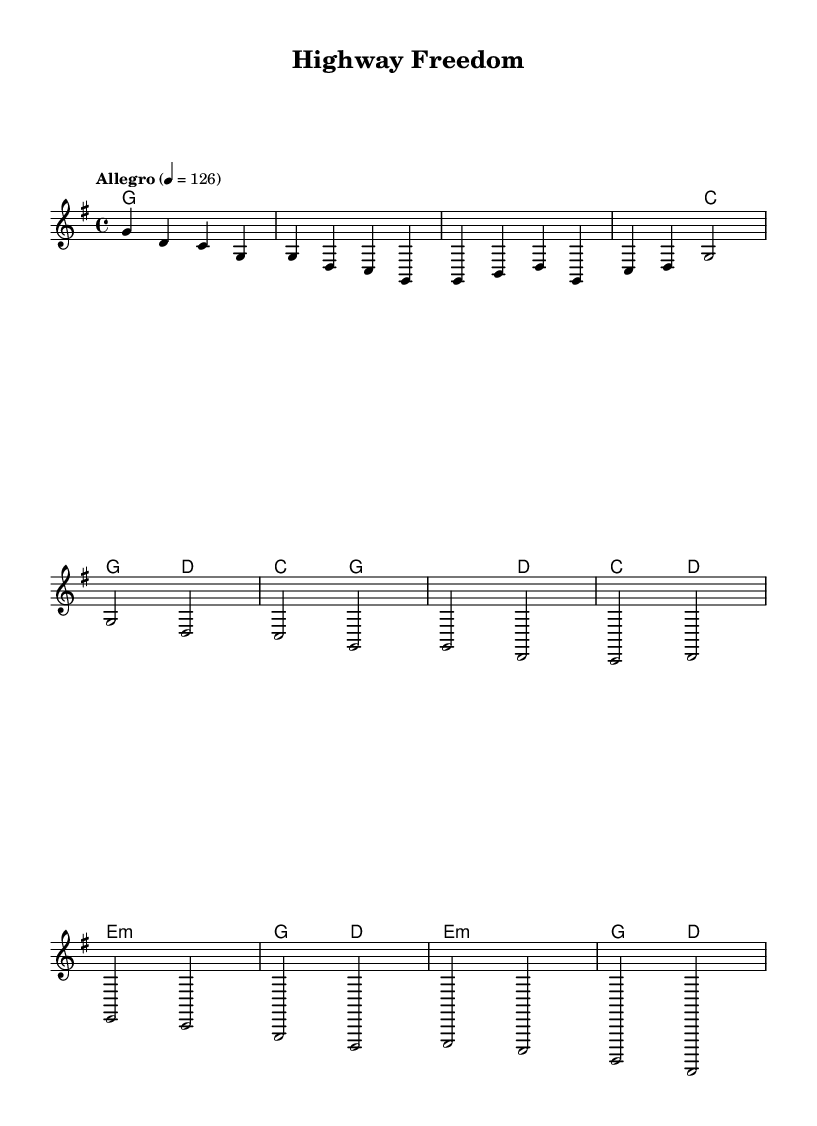What is the key signature of this music? The key signature is indicated by the number of sharps or flats at the beginning of the staff. In this case, the piece is in G major, which has one sharp (F#).
Answer: G major What is the time signature of this piece? The time signature is noted at the beginning of the staff and indicates how many beats are in each measure. Here, it shows 4/4, meaning there are four beats per measure.
Answer: 4/4 What is the tempo marking for this piece? The tempo marking, which indicates the speed of the piece, is found above the staff. It states "Allegro" and the metronome marking is 126, indicating a lively pace.
Answer: Allegro How many measures are there in the chorus section? To find this, we look specifically at the notation for the chorus, counting the measures marked clearly in that section. We find that there are four measures in the chorus.
Answer: 4 What chord is played in the bridge section? The bridge section contains specific chord indications. In analyzing the bridge, we see it alternates between E minor and G major, showcasing the harmonic shift in this part. The first chord listed in the bridge is E minor.
Answer: E minor Which musical form does this tune represent? By examining the structure of the piece, including parts labeled as intro, verse, chorus, and bridge, we can identify that it utilizes a common song structure. Specifically, this piece follows a verse-chorus form typical of country music.
Answer: Verse-chorus What is the first note of the melody in the introduction? The introduction is clearly marked, and the first note indicated in the melody is G, as seen at the beginning of the melodic line.
Answer: G 